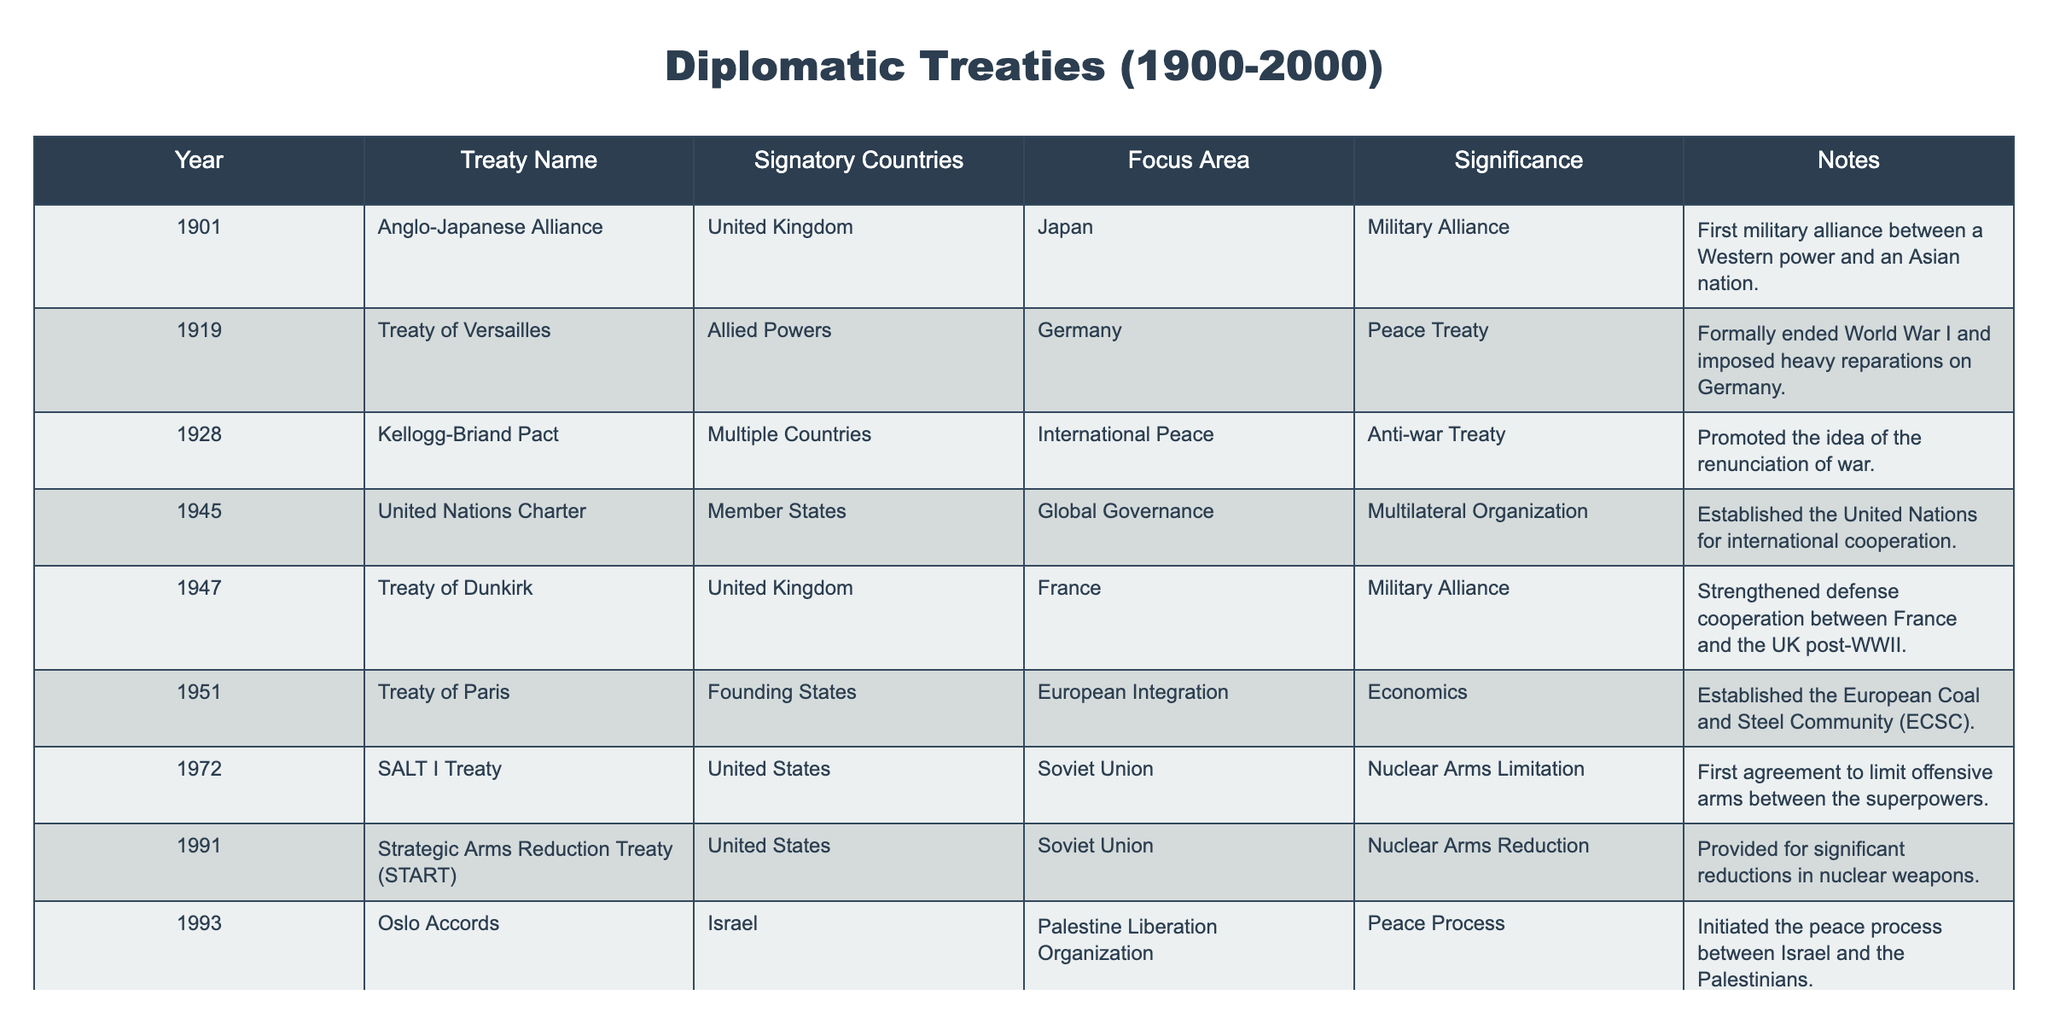What year was the Treaty of Versailles signed? The Treaty of Versailles was listed in the table under the year 1919.
Answer: 1919 What was the focus area of the Oslo Accords? The Oslo Accords had the focus area of the Peace Process as stated in the table.
Answer: Peace Process How many treaties were signed between 1945 and 1950? The treaties signed between 1945 and 1950 are the United Nations Charter (1945) and the Treaty of Dunkirk (1947), which totals 2 treaties.
Answer: 2 Which treaty established the United Nations? The United Nations Charter, listed in the table, established the United Nations for international cooperation.
Answer: United Nations Charter Is the Kellogg-Briand Pact the only anti-war treaty listed in the table? Yes, the Kellogg-Briand Pact is the only treaty identified as an anti-war treaty in the table.
Answer: Yes What was the significance of the Treaty of Paris? The Treaty of Paris was significant because it established the European Coal and Steel Community, which was a step towards European integration.
Answer: Established European integration Which two treaties specifically address nuclear arms? The SALT I Treaty and the Strategic Arms Reduction Treaty (START) both address nuclear arms according to the table.
Answer: SALT I Treaty and START What are the focus areas of the treaties signed by the United States? The United States signed treaties focusing on nuclear arms limitation (SALT I), nuclear arms reduction (START), environmental cooperation (St. Maarten Accord), and military alliances (Anglo-Japanese Alliance).
Answer: Military alliances, Nuclear arms limitation, Nuclear arms reduction, Environmental cooperation Between which years was a military alliance formed between the United Kingdom and France? The military alliance between the United Kingdom and France was formed through the Treaty of Dunkirk, which took place in 1947.
Answer: 1947 Which year saw the signing of an environmental cooperation treaty? The St. Maarten Accord, focused on environmental cooperation, was signed in 1999 as per the table.
Answer: 1999 Was the Kellogg-Briand Pact signed by a single country? No, the Kellogg-Briand Pact was signed by multiple countries as indicated in the table.
Answer: No 